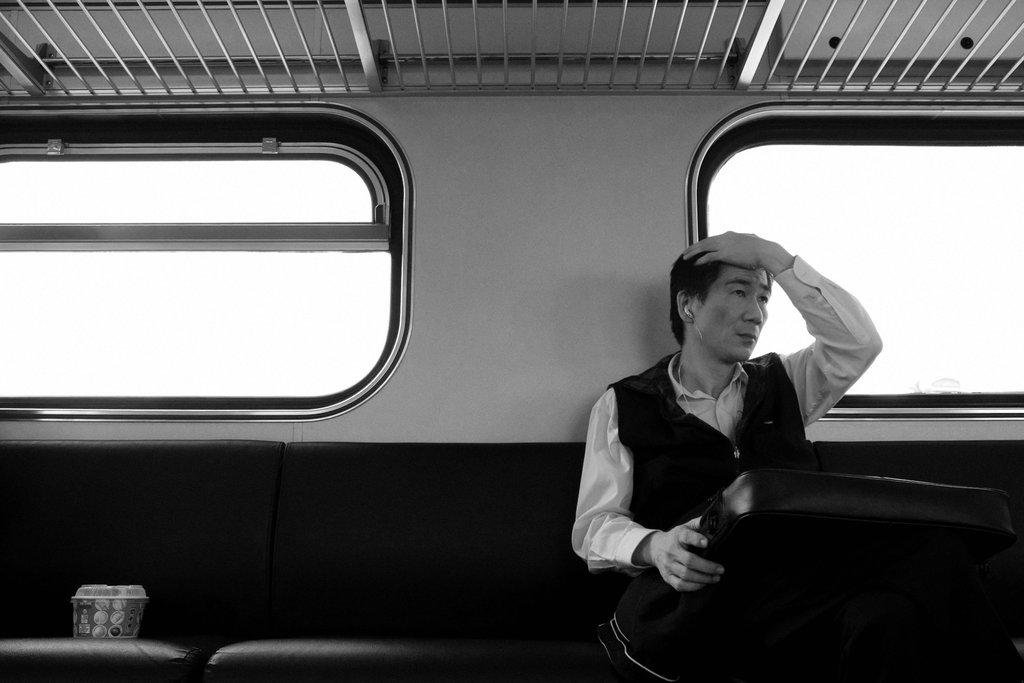What is the main subject of the image? There is a person in the image. What is the person doing in the image? The person is holding an item and sitting on a seat. Where is the person sitting? The person is sitting on a seat inside a vehicle. What else can be seen in the image? There are cups, windows, and iron grills visible in the image. What grade is the baby in the image? There is no baby present in the image. What type of wire can be seen connecting the cups in the image? There is no wire connecting the cups in the image; they are separate objects. 